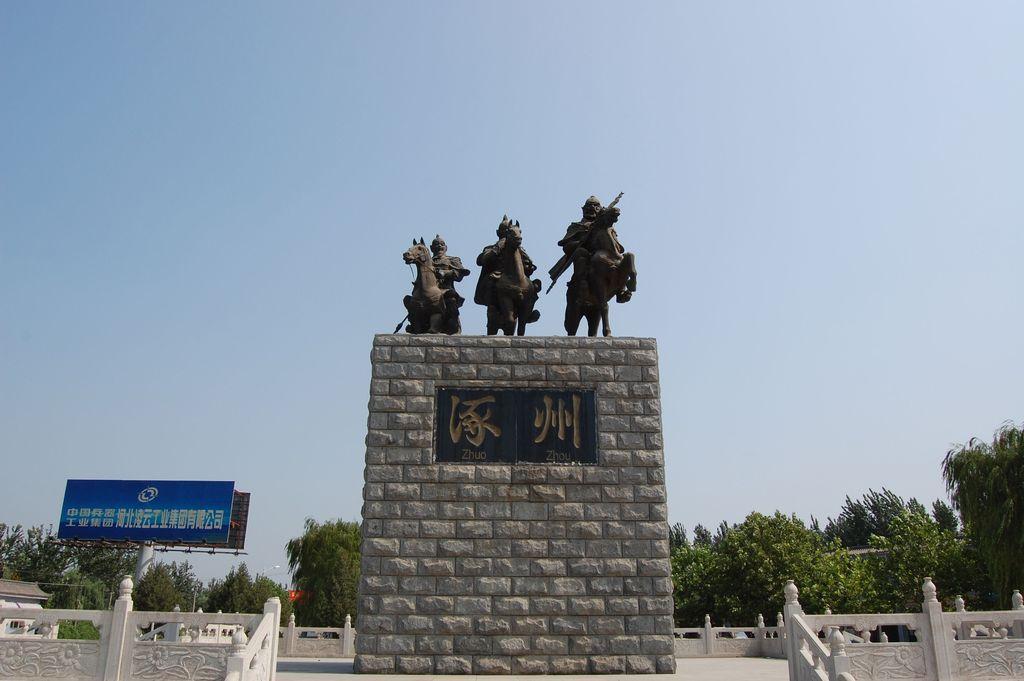Please provide a concise description of this image. Here in this picture we can see statues present on a wall and beside that we can see railing present and on the left side we can see banners present on a pole and we can also see plants and trees covered and we can see the sky is clear. 